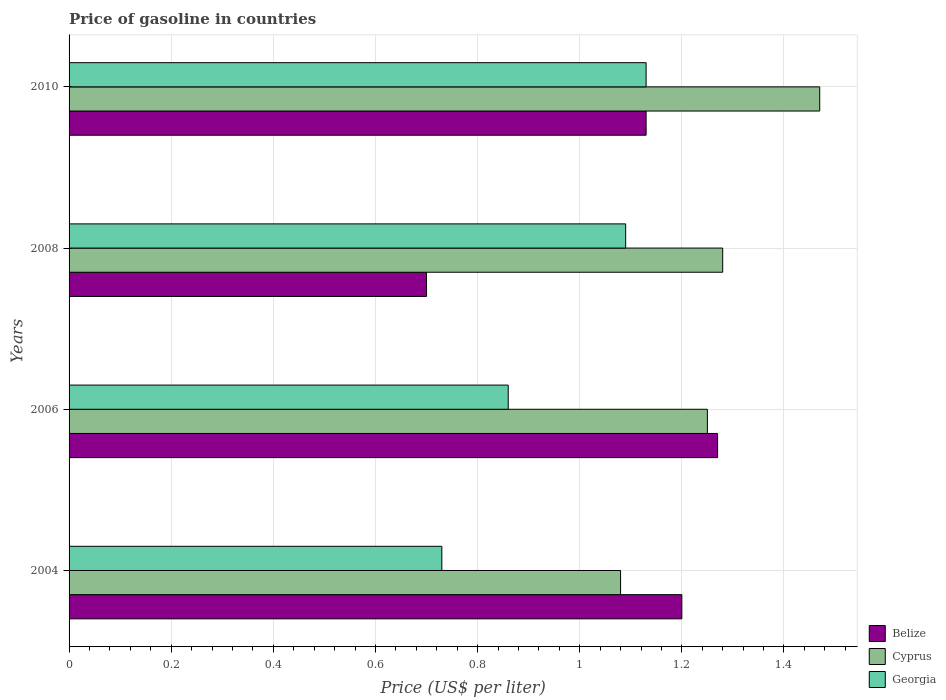How many different coloured bars are there?
Offer a terse response. 3. Are the number of bars per tick equal to the number of legend labels?
Provide a succinct answer. Yes. Are the number of bars on each tick of the Y-axis equal?
Offer a terse response. Yes. In how many cases, is the number of bars for a given year not equal to the number of legend labels?
Your response must be concise. 0. What is the price of gasoline in Cyprus in 2008?
Your response must be concise. 1.28. Across all years, what is the maximum price of gasoline in Georgia?
Give a very brief answer. 1.13. Across all years, what is the minimum price of gasoline in Georgia?
Give a very brief answer. 0.73. In which year was the price of gasoline in Belize minimum?
Make the answer very short. 2008. What is the total price of gasoline in Georgia in the graph?
Your answer should be very brief. 3.81. What is the difference between the price of gasoline in Georgia in 2004 and that in 2010?
Your response must be concise. -0.4. What is the difference between the price of gasoline in Georgia in 2004 and the price of gasoline in Belize in 2008?
Your answer should be very brief. 0.03. What is the average price of gasoline in Georgia per year?
Ensure brevity in your answer.  0.95. In the year 2004, what is the difference between the price of gasoline in Cyprus and price of gasoline in Belize?
Your response must be concise. -0.12. What is the ratio of the price of gasoline in Belize in 2004 to that in 2006?
Offer a very short reply. 0.94. Is the price of gasoline in Georgia in 2006 less than that in 2008?
Keep it short and to the point. Yes. Is the difference between the price of gasoline in Cyprus in 2004 and 2008 greater than the difference between the price of gasoline in Belize in 2004 and 2008?
Your response must be concise. No. What is the difference between the highest and the second highest price of gasoline in Cyprus?
Give a very brief answer. 0.19. What is the difference between the highest and the lowest price of gasoline in Cyprus?
Your answer should be very brief. 0.39. In how many years, is the price of gasoline in Cyprus greater than the average price of gasoline in Cyprus taken over all years?
Offer a very short reply. 2. Is the sum of the price of gasoline in Georgia in 2006 and 2008 greater than the maximum price of gasoline in Belize across all years?
Offer a very short reply. Yes. What does the 3rd bar from the top in 2004 represents?
Make the answer very short. Belize. What does the 2nd bar from the bottom in 2010 represents?
Offer a very short reply. Cyprus. Is it the case that in every year, the sum of the price of gasoline in Belize and price of gasoline in Cyprus is greater than the price of gasoline in Georgia?
Your answer should be compact. Yes. Are all the bars in the graph horizontal?
Offer a terse response. Yes. What is the difference between two consecutive major ticks on the X-axis?
Make the answer very short. 0.2. Does the graph contain any zero values?
Provide a short and direct response. No. How many legend labels are there?
Give a very brief answer. 3. What is the title of the graph?
Your response must be concise. Price of gasoline in countries. Does "Sierra Leone" appear as one of the legend labels in the graph?
Give a very brief answer. No. What is the label or title of the X-axis?
Offer a very short reply. Price (US$ per liter). What is the Price (US$ per liter) in Georgia in 2004?
Keep it short and to the point. 0.73. What is the Price (US$ per liter) of Belize in 2006?
Offer a very short reply. 1.27. What is the Price (US$ per liter) in Georgia in 2006?
Your answer should be compact. 0.86. What is the Price (US$ per liter) in Belize in 2008?
Keep it short and to the point. 0.7. What is the Price (US$ per liter) in Cyprus in 2008?
Give a very brief answer. 1.28. What is the Price (US$ per liter) in Georgia in 2008?
Offer a very short reply. 1.09. What is the Price (US$ per liter) in Belize in 2010?
Provide a short and direct response. 1.13. What is the Price (US$ per liter) in Cyprus in 2010?
Your response must be concise. 1.47. What is the Price (US$ per liter) in Georgia in 2010?
Provide a short and direct response. 1.13. Across all years, what is the maximum Price (US$ per liter) in Belize?
Your answer should be very brief. 1.27. Across all years, what is the maximum Price (US$ per liter) of Cyprus?
Offer a terse response. 1.47. Across all years, what is the maximum Price (US$ per liter) of Georgia?
Keep it short and to the point. 1.13. Across all years, what is the minimum Price (US$ per liter) in Georgia?
Your response must be concise. 0.73. What is the total Price (US$ per liter) of Cyprus in the graph?
Your response must be concise. 5.08. What is the total Price (US$ per liter) of Georgia in the graph?
Give a very brief answer. 3.81. What is the difference between the Price (US$ per liter) of Belize in 2004 and that in 2006?
Provide a succinct answer. -0.07. What is the difference between the Price (US$ per liter) in Cyprus in 2004 and that in 2006?
Your answer should be very brief. -0.17. What is the difference between the Price (US$ per liter) of Georgia in 2004 and that in 2006?
Your answer should be very brief. -0.13. What is the difference between the Price (US$ per liter) in Belize in 2004 and that in 2008?
Provide a short and direct response. 0.5. What is the difference between the Price (US$ per liter) in Cyprus in 2004 and that in 2008?
Offer a terse response. -0.2. What is the difference between the Price (US$ per liter) of Georgia in 2004 and that in 2008?
Keep it short and to the point. -0.36. What is the difference between the Price (US$ per liter) of Belize in 2004 and that in 2010?
Your response must be concise. 0.07. What is the difference between the Price (US$ per liter) of Cyprus in 2004 and that in 2010?
Keep it short and to the point. -0.39. What is the difference between the Price (US$ per liter) of Belize in 2006 and that in 2008?
Provide a succinct answer. 0.57. What is the difference between the Price (US$ per liter) of Cyprus in 2006 and that in 2008?
Give a very brief answer. -0.03. What is the difference between the Price (US$ per liter) in Georgia in 2006 and that in 2008?
Offer a very short reply. -0.23. What is the difference between the Price (US$ per liter) in Belize in 2006 and that in 2010?
Make the answer very short. 0.14. What is the difference between the Price (US$ per liter) of Cyprus in 2006 and that in 2010?
Provide a short and direct response. -0.22. What is the difference between the Price (US$ per liter) of Georgia in 2006 and that in 2010?
Ensure brevity in your answer.  -0.27. What is the difference between the Price (US$ per liter) in Belize in 2008 and that in 2010?
Provide a succinct answer. -0.43. What is the difference between the Price (US$ per liter) of Cyprus in 2008 and that in 2010?
Give a very brief answer. -0.19. What is the difference between the Price (US$ per liter) of Georgia in 2008 and that in 2010?
Offer a very short reply. -0.04. What is the difference between the Price (US$ per liter) in Belize in 2004 and the Price (US$ per liter) in Cyprus in 2006?
Your response must be concise. -0.05. What is the difference between the Price (US$ per liter) of Belize in 2004 and the Price (US$ per liter) of Georgia in 2006?
Make the answer very short. 0.34. What is the difference between the Price (US$ per liter) in Cyprus in 2004 and the Price (US$ per liter) in Georgia in 2006?
Provide a short and direct response. 0.22. What is the difference between the Price (US$ per liter) in Belize in 2004 and the Price (US$ per liter) in Cyprus in 2008?
Keep it short and to the point. -0.08. What is the difference between the Price (US$ per liter) of Belize in 2004 and the Price (US$ per liter) of Georgia in 2008?
Keep it short and to the point. 0.11. What is the difference between the Price (US$ per liter) of Cyprus in 2004 and the Price (US$ per liter) of Georgia in 2008?
Provide a succinct answer. -0.01. What is the difference between the Price (US$ per liter) in Belize in 2004 and the Price (US$ per liter) in Cyprus in 2010?
Offer a very short reply. -0.27. What is the difference between the Price (US$ per liter) of Belize in 2004 and the Price (US$ per liter) of Georgia in 2010?
Provide a succinct answer. 0.07. What is the difference between the Price (US$ per liter) in Belize in 2006 and the Price (US$ per liter) in Cyprus in 2008?
Ensure brevity in your answer.  -0.01. What is the difference between the Price (US$ per liter) of Belize in 2006 and the Price (US$ per liter) of Georgia in 2008?
Offer a terse response. 0.18. What is the difference between the Price (US$ per liter) of Cyprus in 2006 and the Price (US$ per liter) of Georgia in 2008?
Provide a succinct answer. 0.16. What is the difference between the Price (US$ per liter) in Belize in 2006 and the Price (US$ per liter) in Georgia in 2010?
Provide a succinct answer. 0.14. What is the difference between the Price (US$ per liter) of Cyprus in 2006 and the Price (US$ per liter) of Georgia in 2010?
Ensure brevity in your answer.  0.12. What is the difference between the Price (US$ per liter) of Belize in 2008 and the Price (US$ per liter) of Cyprus in 2010?
Offer a very short reply. -0.77. What is the difference between the Price (US$ per liter) in Belize in 2008 and the Price (US$ per liter) in Georgia in 2010?
Your answer should be compact. -0.43. What is the average Price (US$ per liter) in Belize per year?
Keep it short and to the point. 1.07. What is the average Price (US$ per liter) in Cyprus per year?
Ensure brevity in your answer.  1.27. What is the average Price (US$ per liter) in Georgia per year?
Your response must be concise. 0.95. In the year 2004, what is the difference between the Price (US$ per liter) of Belize and Price (US$ per liter) of Cyprus?
Your answer should be very brief. 0.12. In the year 2004, what is the difference between the Price (US$ per liter) in Belize and Price (US$ per liter) in Georgia?
Provide a succinct answer. 0.47. In the year 2004, what is the difference between the Price (US$ per liter) in Cyprus and Price (US$ per liter) in Georgia?
Your answer should be compact. 0.35. In the year 2006, what is the difference between the Price (US$ per liter) of Belize and Price (US$ per liter) of Cyprus?
Give a very brief answer. 0.02. In the year 2006, what is the difference between the Price (US$ per liter) in Belize and Price (US$ per liter) in Georgia?
Offer a very short reply. 0.41. In the year 2006, what is the difference between the Price (US$ per liter) in Cyprus and Price (US$ per liter) in Georgia?
Provide a short and direct response. 0.39. In the year 2008, what is the difference between the Price (US$ per liter) of Belize and Price (US$ per liter) of Cyprus?
Give a very brief answer. -0.58. In the year 2008, what is the difference between the Price (US$ per liter) in Belize and Price (US$ per liter) in Georgia?
Offer a terse response. -0.39. In the year 2008, what is the difference between the Price (US$ per liter) in Cyprus and Price (US$ per liter) in Georgia?
Provide a short and direct response. 0.19. In the year 2010, what is the difference between the Price (US$ per liter) of Belize and Price (US$ per liter) of Cyprus?
Your answer should be compact. -0.34. In the year 2010, what is the difference between the Price (US$ per liter) in Cyprus and Price (US$ per liter) in Georgia?
Your response must be concise. 0.34. What is the ratio of the Price (US$ per liter) in Belize in 2004 to that in 2006?
Your response must be concise. 0.94. What is the ratio of the Price (US$ per liter) in Cyprus in 2004 to that in 2006?
Your response must be concise. 0.86. What is the ratio of the Price (US$ per liter) of Georgia in 2004 to that in 2006?
Provide a short and direct response. 0.85. What is the ratio of the Price (US$ per liter) of Belize in 2004 to that in 2008?
Your answer should be compact. 1.71. What is the ratio of the Price (US$ per liter) of Cyprus in 2004 to that in 2008?
Keep it short and to the point. 0.84. What is the ratio of the Price (US$ per liter) of Georgia in 2004 to that in 2008?
Your answer should be compact. 0.67. What is the ratio of the Price (US$ per liter) of Belize in 2004 to that in 2010?
Provide a succinct answer. 1.06. What is the ratio of the Price (US$ per liter) of Cyprus in 2004 to that in 2010?
Provide a short and direct response. 0.73. What is the ratio of the Price (US$ per liter) in Georgia in 2004 to that in 2010?
Your answer should be compact. 0.65. What is the ratio of the Price (US$ per liter) in Belize in 2006 to that in 2008?
Give a very brief answer. 1.81. What is the ratio of the Price (US$ per liter) in Cyprus in 2006 to that in 2008?
Your response must be concise. 0.98. What is the ratio of the Price (US$ per liter) of Georgia in 2006 to that in 2008?
Your answer should be compact. 0.79. What is the ratio of the Price (US$ per liter) in Belize in 2006 to that in 2010?
Give a very brief answer. 1.12. What is the ratio of the Price (US$ per liter) in Cyprus in 2006 to that in 2010?
Your answer should be very brief. 0.85. What is the ratio of the Price (US$ per liter) in Georgia in 2006 to that in 2010?
Your answer should be very brief. 0.76. What is the ratio of the Price (US$ per liter) of Belize in 2008 to that in 2010?
Provide a short and direct response. 0.62. What is the ratio of the Price (US$ per liter) in Cyprus in 2008 to that in 2010?
Your answer should be very brief. 0.87. What is the ratio of the Price (US$ per liter) of Georgia in 2008 to that in 2010?
Make the answer very short. 0.96. What is the difference between the highest and the second highest Price (US$ per liter) in Belize?
Give a very brief answer. 0.07. What is the difference between the highest and the second highest Price (US$ per liter) of Cyprus?
Provide a succinct answer. 0.19. What is the difference between the highest and the second highest Price (US$ per liter) in Georgia?
Offer a very short reply. 0.04. What is the difference between the highest and the lowest Price (US$ per liter) of Belize?
Your response must be concise. 0.57. What is the difference between the highest and the lowest Price (US$ per liter) in Cyprus?
Your answer should be compact. 0.39. What is the difference between the highest and the lowest Price (US$ per liter) of Georgia?
Your answer should be compact. 0.4. 